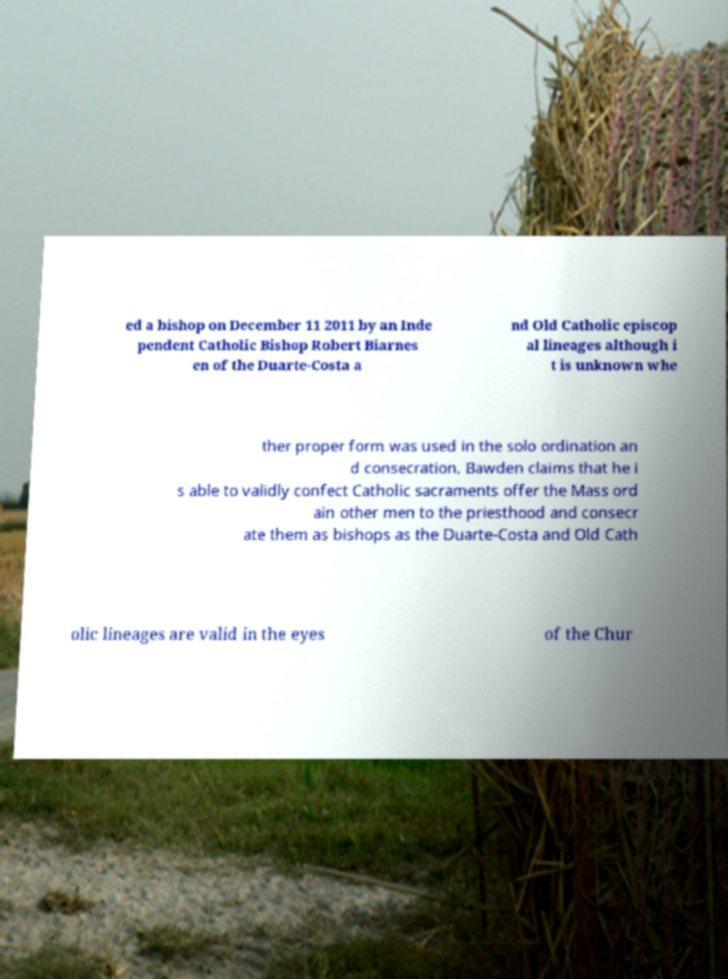Please read and relay the text visible in this image. What does it say? ed a bishop on December 11 2011 by an Inde pendent Catholic Bishop Robert Biarnes en of the Duarte-Costa a nd Old Catholic episcop al lineages although i t is unknown whe ther proper form was used in the solo ordination an d consecration. Bawden claims that he i s able to validly confect Catholic sacraments offer the Mass ord ain other men to the priesthood and consecr ate them as bishops as the Duarte-Costa and Old Cath olic lineages are valid in the eyes of the Chur 